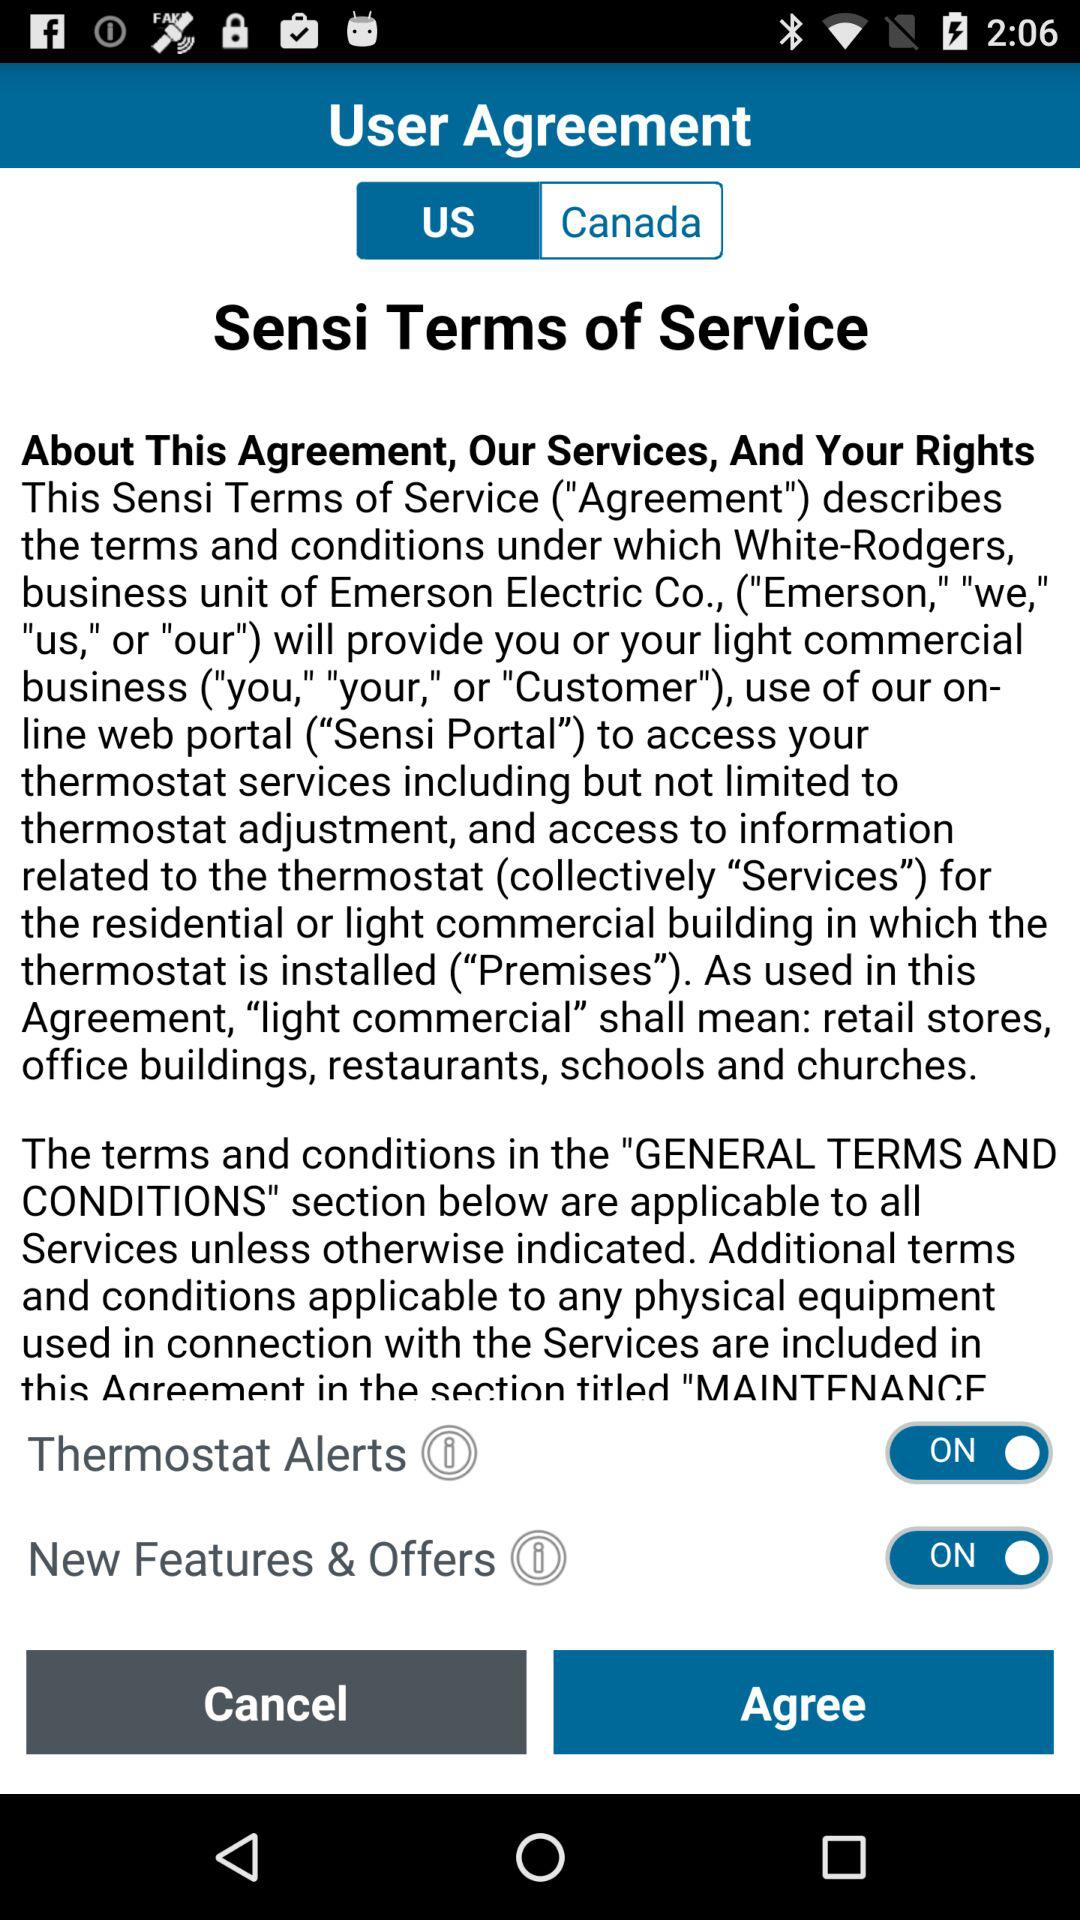What is the status of "New Features & Offers"? The status of "New Features & Offers" is "on". 